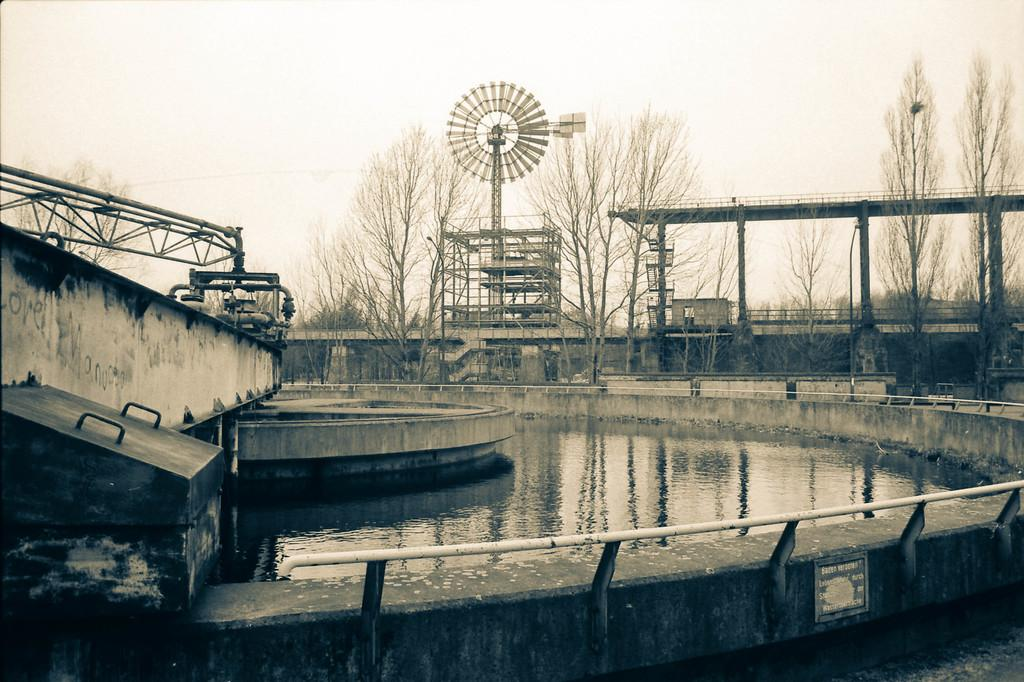What is the primary element visible in the image? There is water in the image. What structures can be seen in the image? There is a railing, a board, poles, a tower, and a bridge in the image. What type of vegetation is present in the image? There are trees in the image. What else can be seen in the image besides the structures and vegetation? There are objects in the image. What is visible in the background of the image? The sky is visible in the background of the image. How many sisters are crying in the image? There are no people, let alone sisters, present in the image. The image primarily features water, structures, and vegetation. 